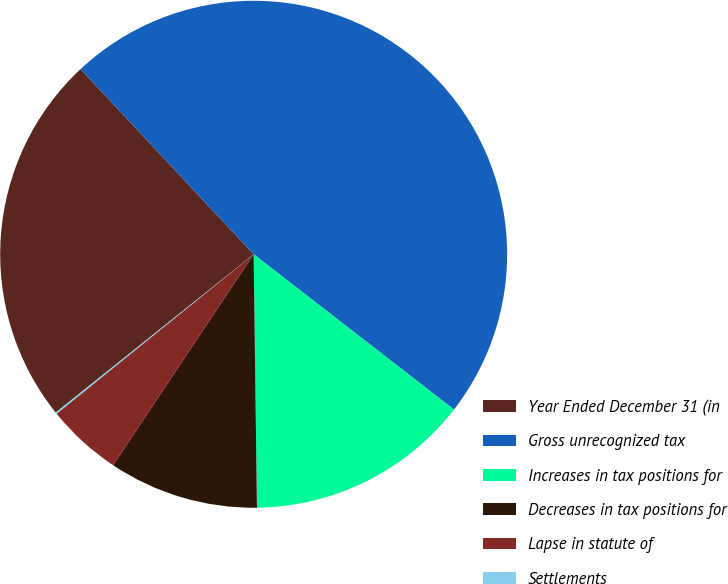Convert chart to OTSL. <chart><loc_0><loc_0><loc_500><loc_500><pie_chart><fcel>Year Ended December 31 (in<fcel>Gross unrecognized tax<fcel>Increases in tax positions for<fcel>Decreases in tax positions for<fcel>Lapse in statute of<fcel>Settlements<nl><fcel>23.77%<fcel>47.46%<fcel>14.3%<fcel>9.56%<fcel>4.82%<fcel>0.09%<nl></chart> 